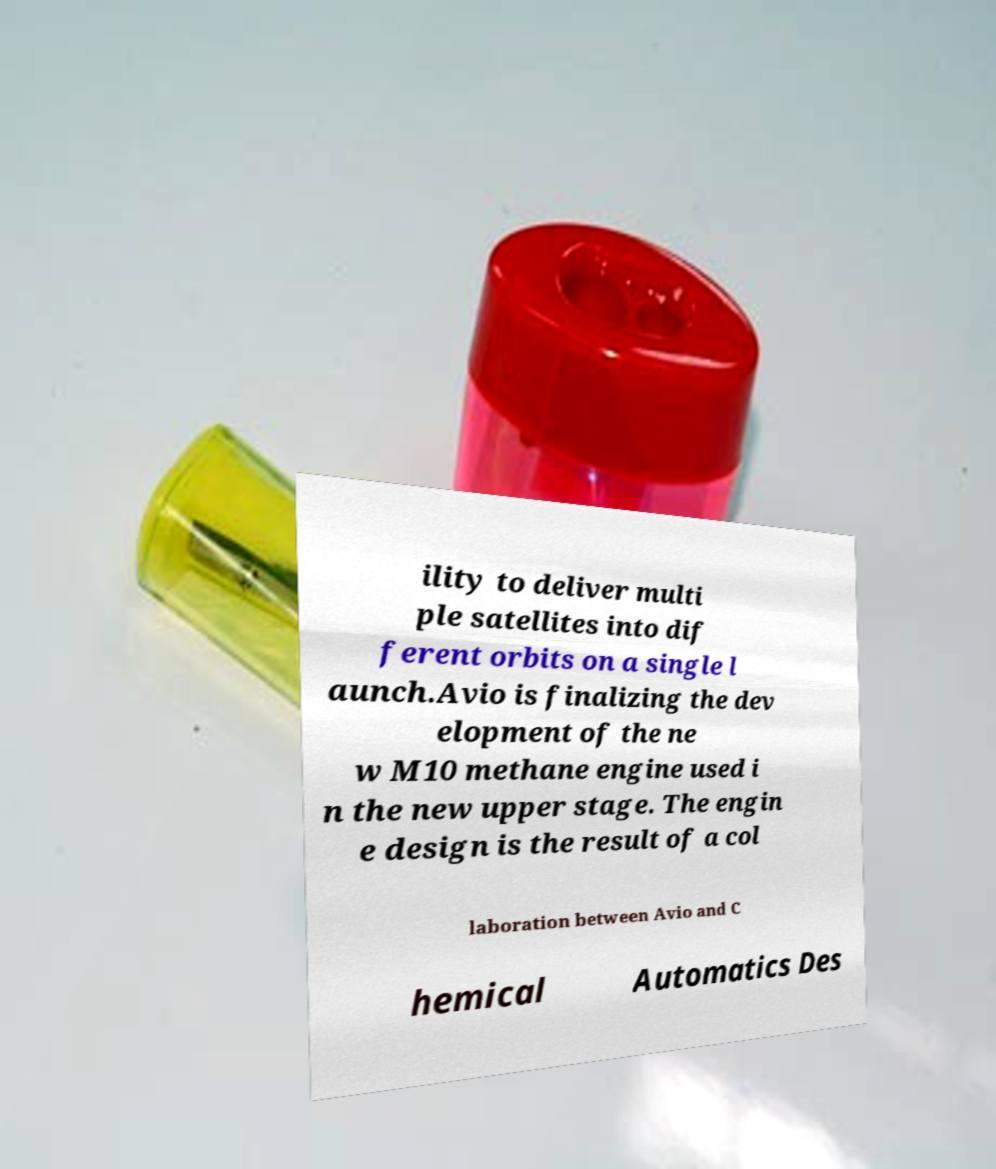Can you accurately transcribe the text from the provided image for me? ility to deliver multi ple satellites into dif ferent orbits on a single l aunch.Avio is finalizing the dev elopment of the ne w M10 methane engine used i n the new upper stage. The engin e design is the result of a col laboration between Avio and C hemical Automatics Des 